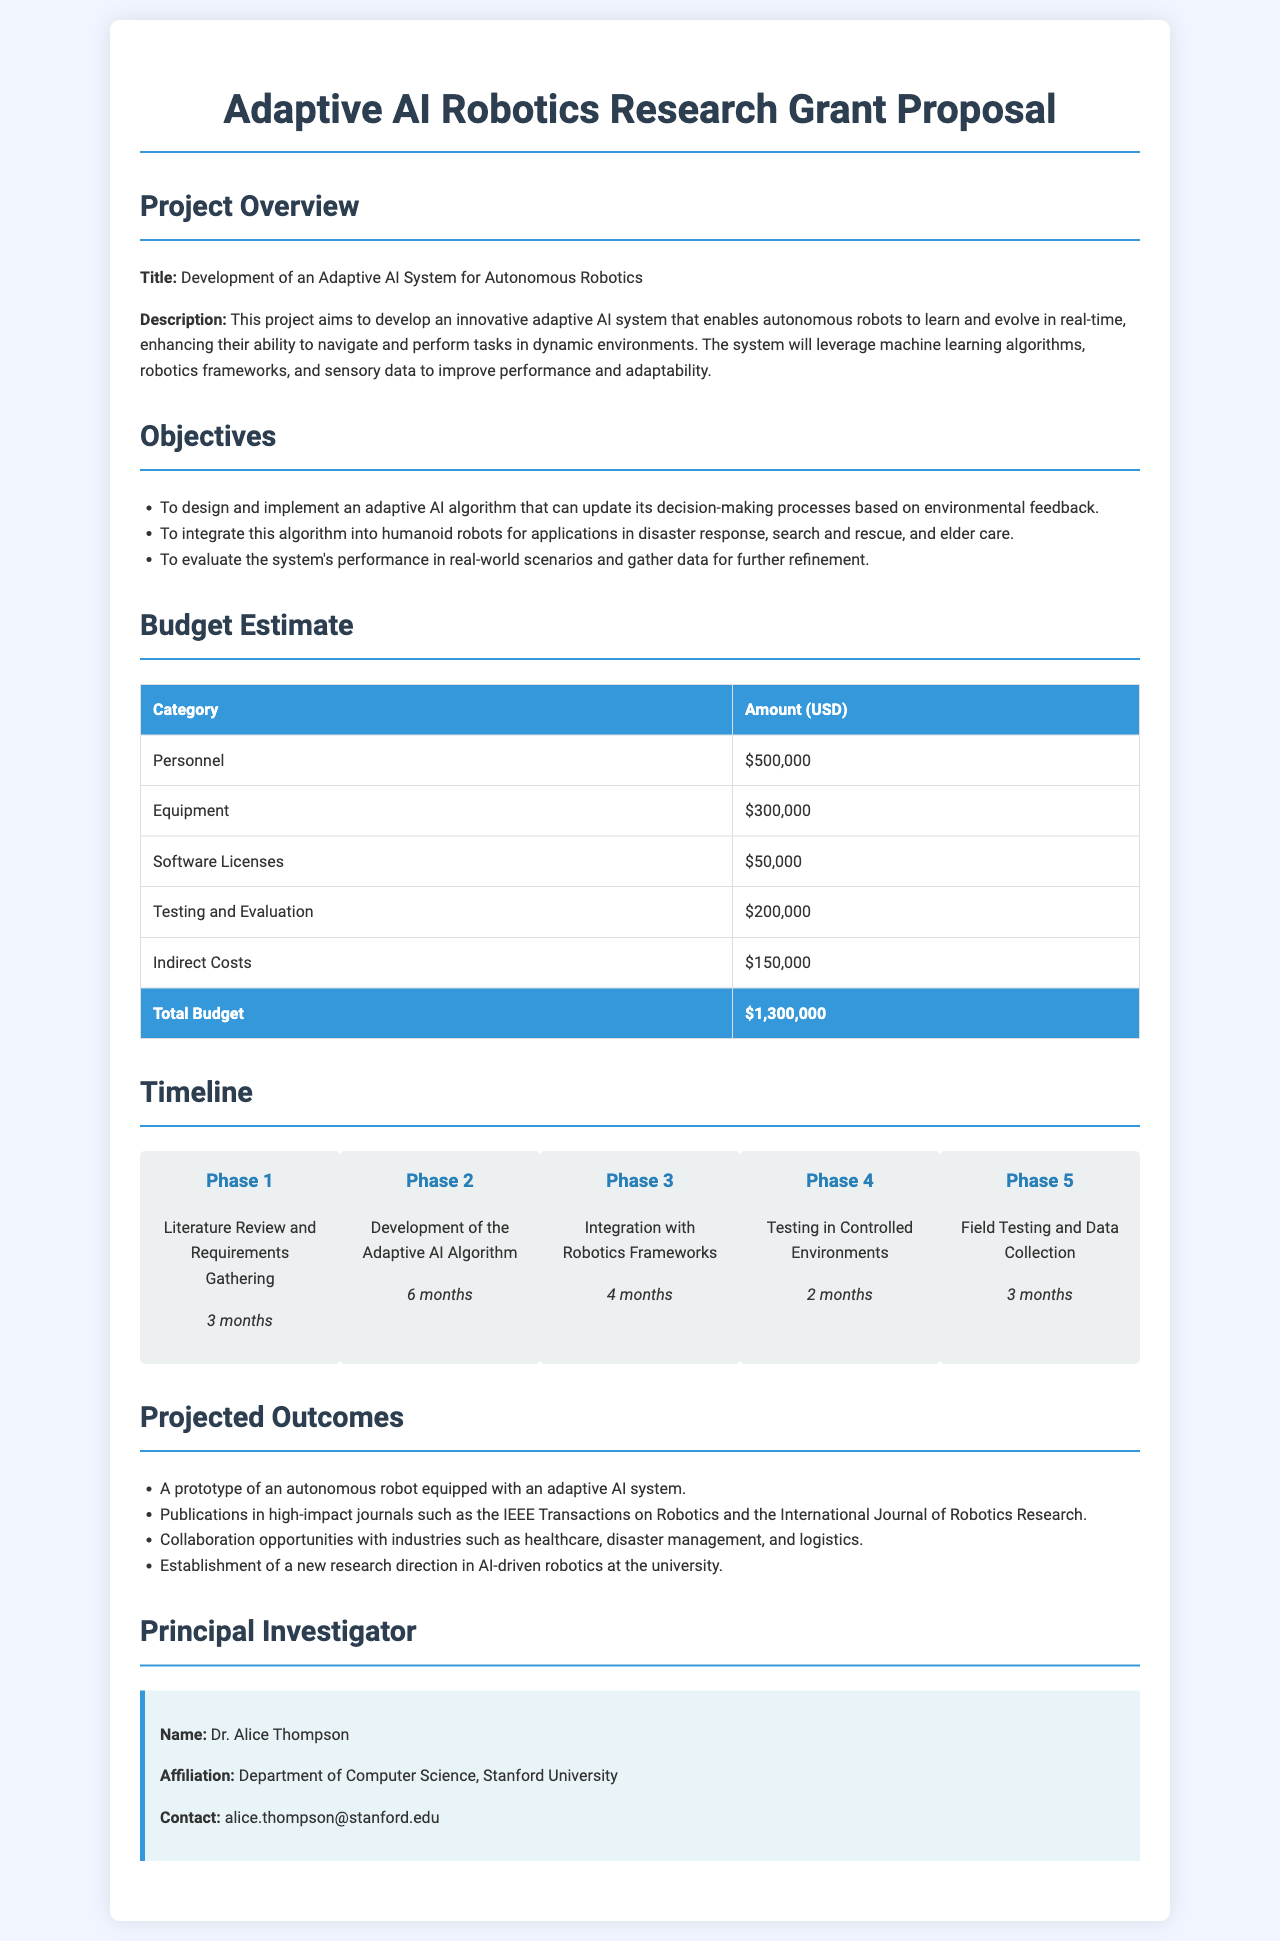What is the title of the project? The title of the project is specified in the document under Project Overview.
Answer: Development of an Adaptive AI System for Autonomous Robotics What is the total budget estimate for the project? The total budget is provided in the Budget Estimate section of the document.
Answer: $1,300,000 Who is the Principal Investigator? The name of the Principal Investigator is mentioned in the Principal Investigator section.
Answer: Dr. Alice Thompson How long is Phase 2 scheduled to take? The duration of Phase 2 is stated in the Timeline section of the document.
Answer: 6 months What primary method will the AI system use to enhance performance? The method is described under Project Overview; it indicates what the adaptive AI system will leverage.
Answer: Machine learning algorithms What is one of the applications for the integrated AI algorithm? The applications are detailed in the Objectives section, which states possible use cases.
Answer: Disaster response What is the budget allocated for Equipment? The budget for this category can be found in the Budget Estimate section of the document.
Answer: $300,000 What is the purpose of Phase 4? The purpose is listed in the Timeline section, highlighting the activities planned for that phase.
Answer: Testing in Controlled Environments In which journals does the project aim to publish results? The expected publications are noted under Projected Outcomes in the document.
Answer: IEEE Transactions on Robotics and the International Journal of Robotics Research 